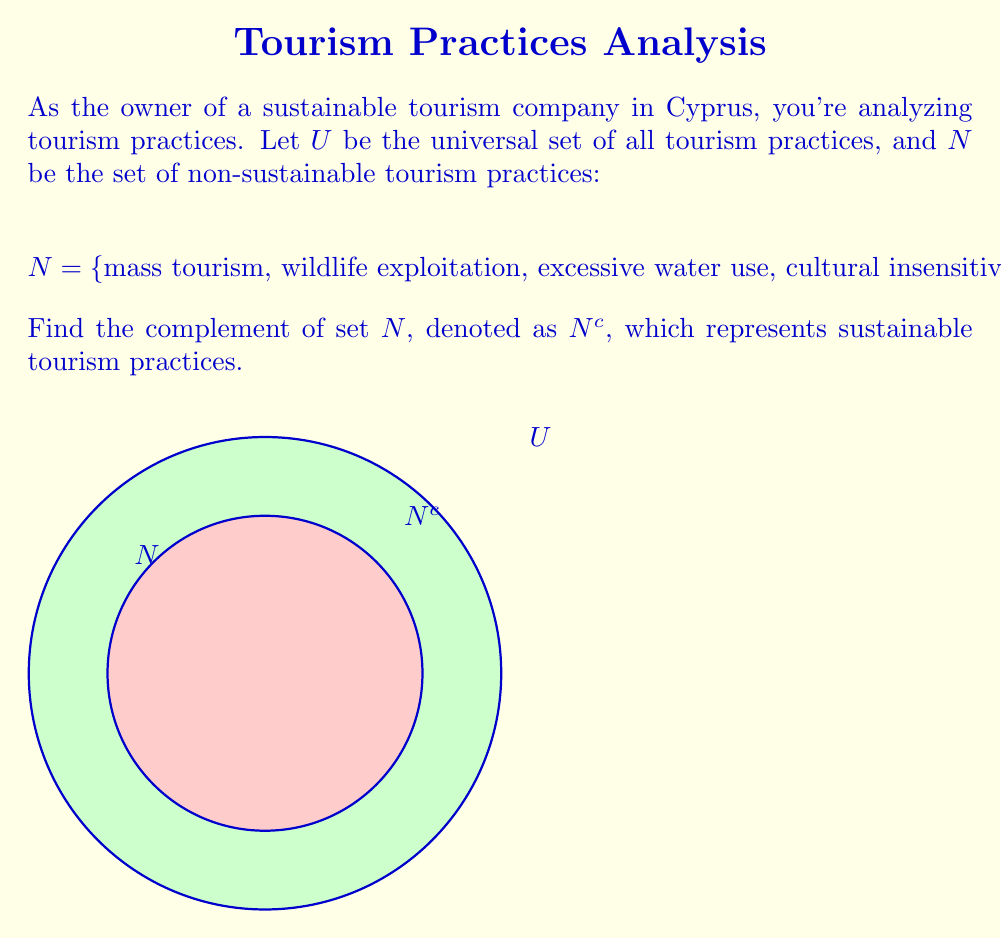Could you help me with this problem? To find the complement of set $N$, we need to identify all elements in the universal set $U$ that are not in set $N$. This can be done through the following steps:

1) First, let's consider what the universal set $U$ might include. It would contain all possible tourism practices, both sustainable and non-sustainable.

2) The complement $N^c$ will include all elements in $U$ that are not in $N$. In set theory notation, this is expressed as:

   $N^c = U \setminus N$

3) While we don't have an exhaustive list of all elements in $U$, we can deduce some elements that would be in $N^c$ based on sustainable tourism practices:

   - Eco-friendly accommodations
   - Local community engagement
   - Conservation activities
   - Responsible wildlife viewing
   - Sustainable transportation
   - Cultural preservation

4) Mathematically, we can express $N^c$ as:

   $N^c = \{x \in U : x \notin N\}$

   This reads as "the set of all elements $x$ in $U$ such that $x$ is not in $N$".

5) In the context of sustainable tourism in Cyprus, $N^c$ would represent all practices that promote ecological balance, respect local cultures, and contribute to the local economy without depleting natural resources.
Answer: $N^c = \{x \in U : x \notin N\}$ 